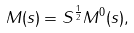Convert formula to latex. <formula><loc_0><loc_0><loc_500><loc_500>M ( s ) = S ^ { \frac { 1 } { 2 } } M ^ { 0 } ( s ) ,</formula> 